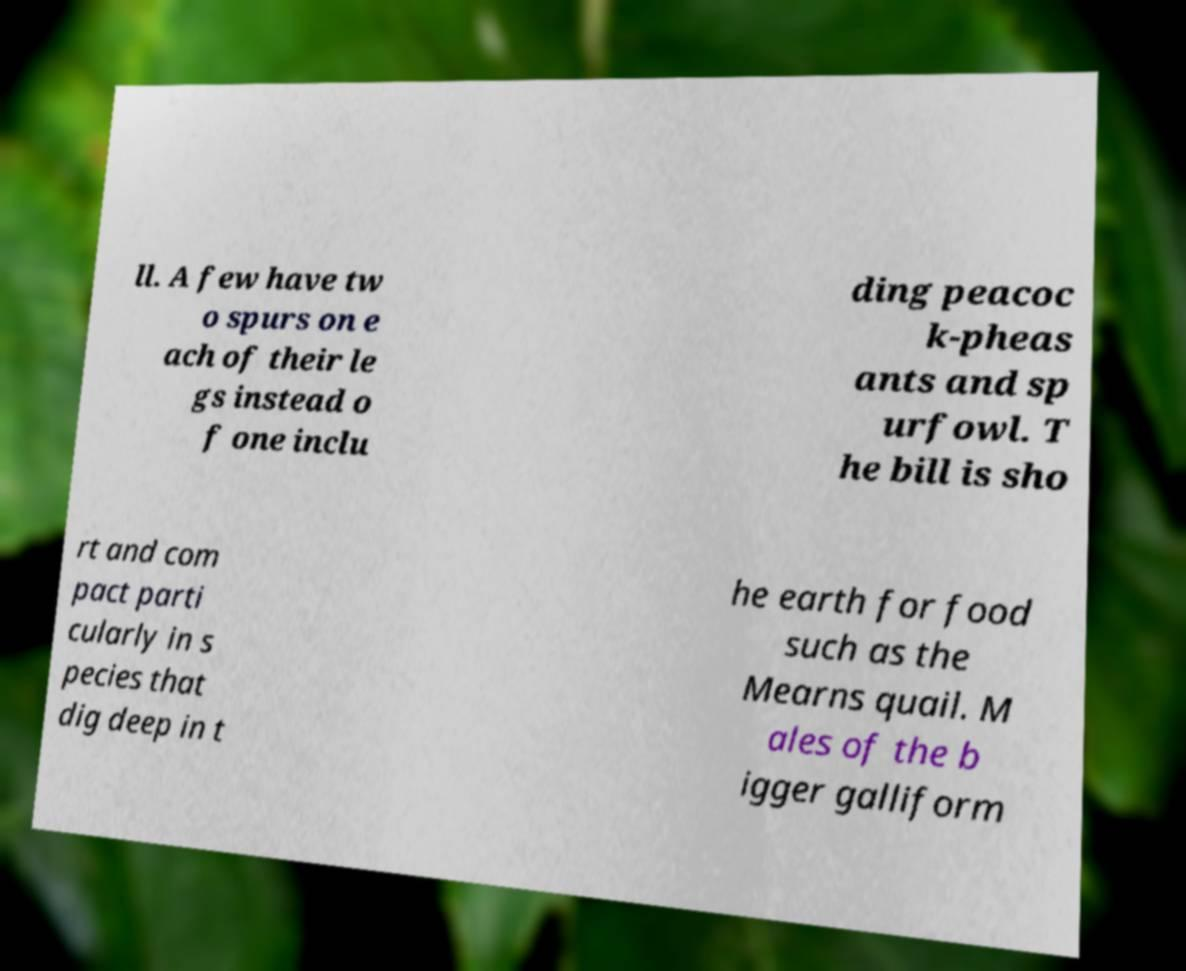There's text embedded in this image that I need extracted. Can you transcribe it verbatim? ll. A few have tw o spurs on e ach of their le gs instead o f one inclu ding peacoc k-pheas ants and sp urfowl. T he bill is sho rt and com pact parti cularly in s pecies that dig deep in t he earth for food such as the Mearns quail. M ales of the b igger galliform 